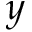Convert formula to latex. <formula><loc_0><loc_0><loc_500><loc_500>y</formula> 